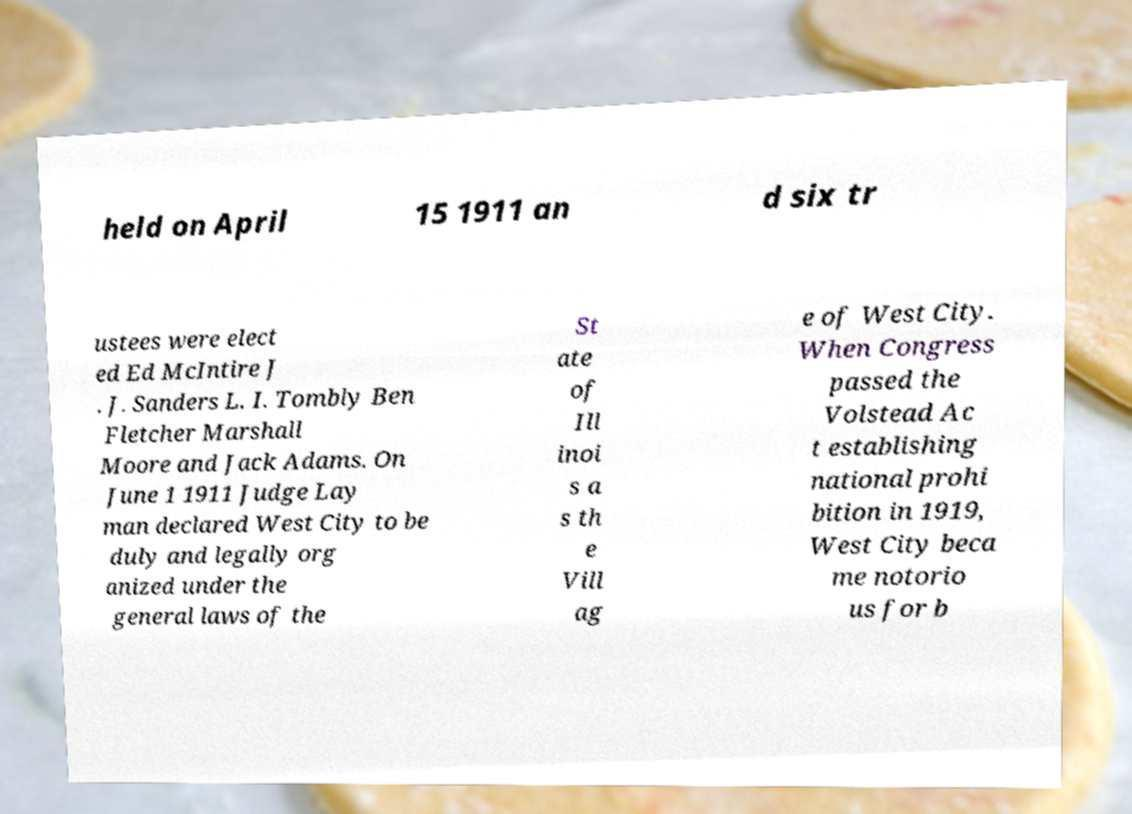For documentation purposes, I need the text within this image transcribed. Could you provide that? held on April 15 1911 an d six tr ustees were elect ed Ed McIntire J . J. Sanders L. I. Tombly Ben Fletcher Marshall Moore and Jack Adams. On June 1 1911 Judge Lay man declared West City to be duly and legally org anized under the general laws of the St ate of Ill inoi s a s th e Vill ag e of West City. When Congress passed the Volstead Ac t establishing national prohi bition in 1919, West City beca me notorio us for b 